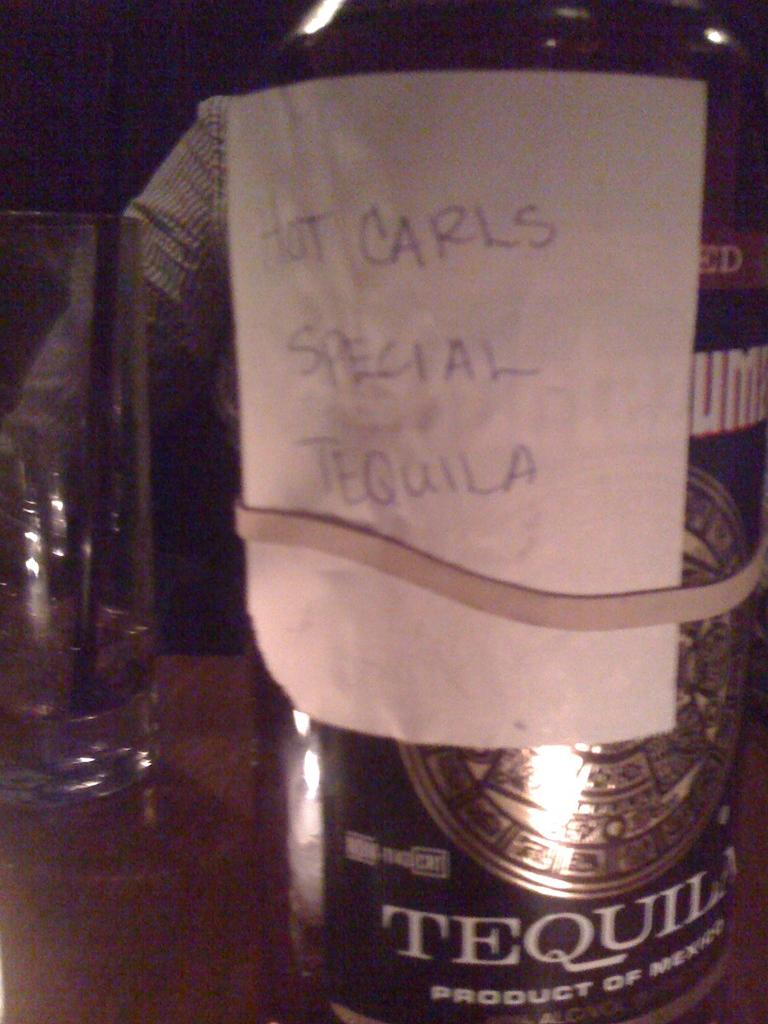<image>
Present a compact description of the photo's key features. A bottle with a written note designating it Hot Carls Special Tequila is held on with a rubber band. 